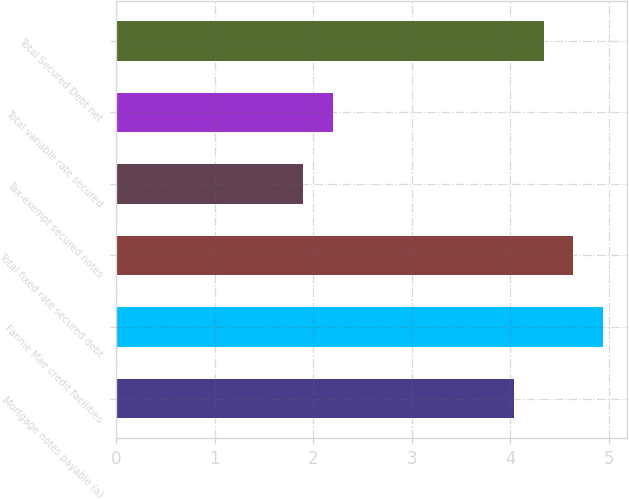Convert chart to OTSL. <chart><loc_0><loc_0><loc_500><loc_500><bar_chart><fcel>Mortgage notes payable (a)<fcel>Fannie Mae credit facilities<fcel>Total fixed rate secured debt<fcel>Tax-exempt secured notes<fcel>Total variable rate secured<fcel>Total Secured Debt net<nl><fcel>4.04<fcel>4.94<fcel>4.64<fcel>1.9<fcel>2.2<fcel>4.34<nl></chart> 